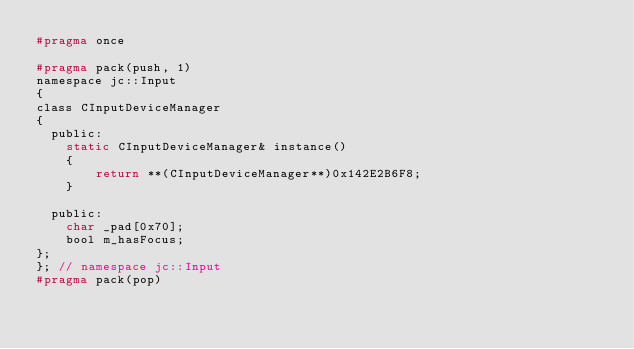<code> <loc_0><loc_0><loc_500><loc_500><_C_>#pragma once

#pragma pack(push, 1)
namespace jc::Input
{
class CInputDeviceManager
{
  public:
    static CInputDeviceManager& instance()
    {
        return **(CInputDeviceManager**)0x142E2B6F8;
    }

  public:
    char _pad[0x70];
    bool m_hasFocus;
};
}; // namespace jc::Input
#pragma pack(pop)
</code> 